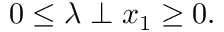<formula> <loc_0><loc_0><loc_500><loc_500>0 \leq \lambda \perp x _ { 1 } \geq 0 .</formula> 